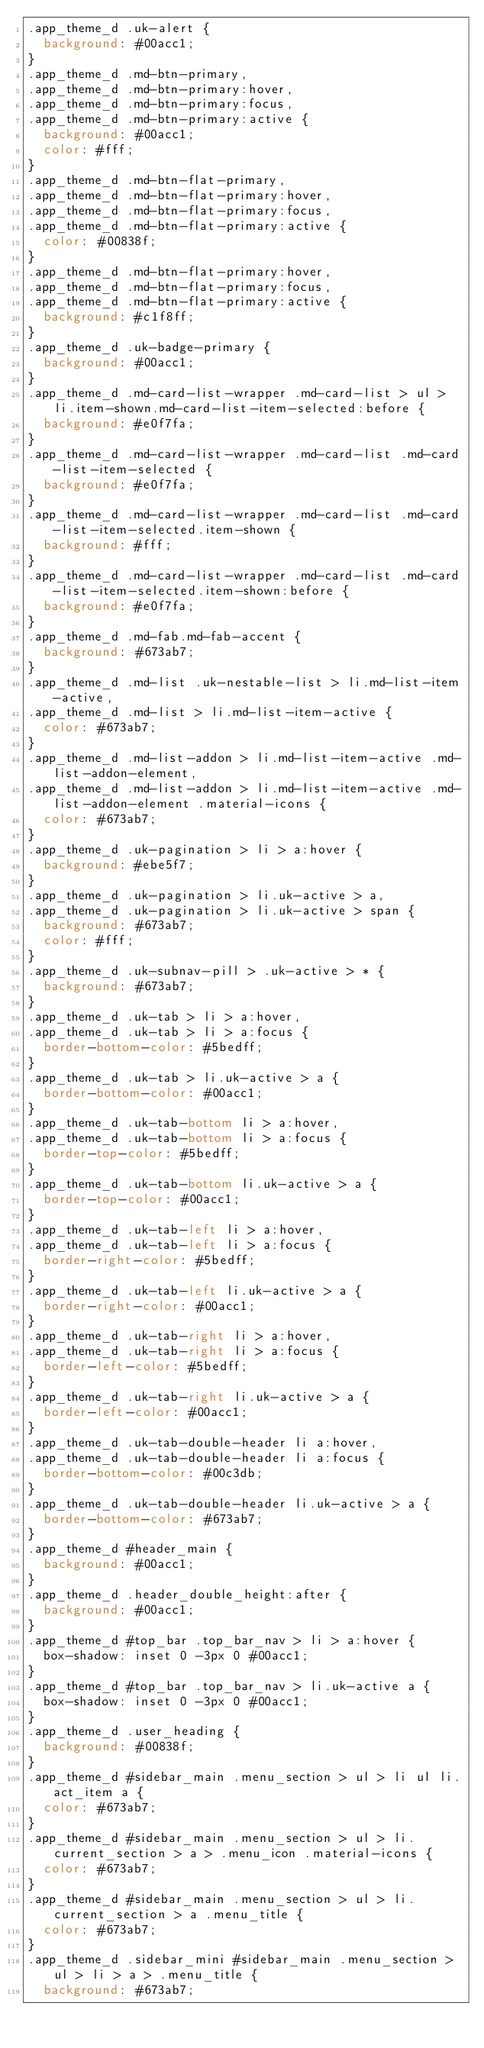<code> <loc_0><loc_0><loc_500><loc_500><_CSS_>.app_theme_d .uk-alert {
  background: #00acc1;
}
.app_theme_d .md-btn-primary,
.app_theme_d .md-btn-primary:hover,
.app_theme_d .md-btn-primary:focus,
.app_theme_d .md-btn-primary:active {
  background: #00acc1;
  color: #fff;
}
.app_theme_d .md-btn-flat-primary,
.app_theme_d .md-btn-flat-primary:hover,
.app_theme_d .md-btn-flat-primary:focus,
.app_theme_d .md-btn-flat-primary:active {
  color: #00838f;
}
.app_theme_d .md-btn-flat-primary:hover,
.app_theme_d .md-btn-flat-primary:focus,
.app_theme_d .md-btn-flat-primary:active {
  background: #c1f8ff;
}
.app_theme_d .uk-badge-primary {
  background: #00acc1;
}
.app_theme_d .md-card-list-wrapper .md-card-list > ul > li.item-shown.md-card-list-item-selected:before {
  background: #e0f7fa;
}
.app_theme_d .md-card-list-wrapper .md-card-list .md-card-list-item-selected {
  background: #e0f7fa;
}
.app_theme_d .md-card-list-wrapper .md-card-list .md-card-list-item-selected.item-shown {
  background: #fff;
}
.app_theme_d .md-card-list-wrapper .md-card-list .md-card-list-item-selected.item-shown:before {
  background: #e0f7fa;
}
.app_theme_d .md-fab.md-fab-accent {
  background: #673ab7;
}
.app_theme_d .md-list .uk-nestable-list > li.md-list-item-active,
.app_theme_d .md-list > li.md-list-item-active {
  color: #673ab7;
}
.app_theme_d .md-list-addon > li.md-list-item-active .md-list-addon-element,
.app_theme_d .md-list-addon > li.md-list-item-active .md-list-addon-element .material-icons {
  color: #673ab7;
}
.app_theme_d .uk-pagination > li > a:hover {
  background: #ebe5f7;
}
.app_theme_d .uk-pagination > li.uk-active > a,
.app_theme_d .uk-pagination > li.uk-active > span {
  background: #673ab7;
  color: #fff;
}
.app_theme_d .uk-subnav-pill > .uk-active > * {
  background: #673ab7;
}
.app_theme_d .uk-tab > li > a:hover,
.app_theme_d .uk-tab > li > a:focus {
  border-bottom-color: #5bedff;
}
.app_theme_d .uk-tab > li.uk-active > a {
  border-bottom-color: #00acc1;
}
.app_theme_d .uk-tab-bottom li > a:hover,
.app_theme_d .uk-tab-bottom li > a:focus {
  border-top-color: #5bedff;
}
.app_theme_d .uk-tab-bottom li.uk-active > a {
  border-top-color: #00acc1;
}
.app_theme_d .uk-tab-left li > a:hover,
.app_theme_d .uk-tab-left li > a:focus {
  border-right-color: #5bedff;
}
.app_theme_d .uk-tab-left li.uk-active > a {
  border-right-color: #00acc1;
}
.app_theme_d .uk-tab-right li > a:hover,
.app_theme_d .uk-tab-right li > a:focus {
  border-left-color: #5bedff;
}
.app_theme_d .uk-tab-right li.uk-active > a {
  border-left-color: #00acc1;
}
.app_theme_d .uk-tab-double-header li a:hover,
.app_theme_d .uk-tab-double-header li a:focus {
  border-bottom-color: #00c3db;
}
.app_theme_d .uk-tab-double-header li.uk-active > a {
  border-bottom-color: #673ab7;
}
.app_theme_d #header_main {
  background: #00acc1;
}
.app_theme_d .header_double_height:after {
  background: #00acc1;
}
.app_theme_d #top_bar .top_bar_nav > li > a:hover {
  box-shadow: inset 0 -3px 0 #00acc1;
}
.app_theme_d #top_bar .top_bar_nav > li.uk-active a {
  box-shadow: inset 0 -3px 0 #00acc1;
}
.app_theme_d .user_heading {
  background: #00838f;
}
.app_theme_d #sidebar_main .menu_section > ul > li ul li.act_item a {
  color: #673ab7;
}
.app_theme_d #sidebar_main .menu_section > ul > li.current_section > a > .menu_icon .material-icons {
  color: #673ab7;
}
.app_theme_d #sidebar_main .menu_section > ul > li.current_section > a .menu_title {
  color: #673ab7;
}
.app_theme_d .sidebar_mini #sidebar_main .menu_section > ul > li > a > .menu_title {
  background: #673ab7;</code> 